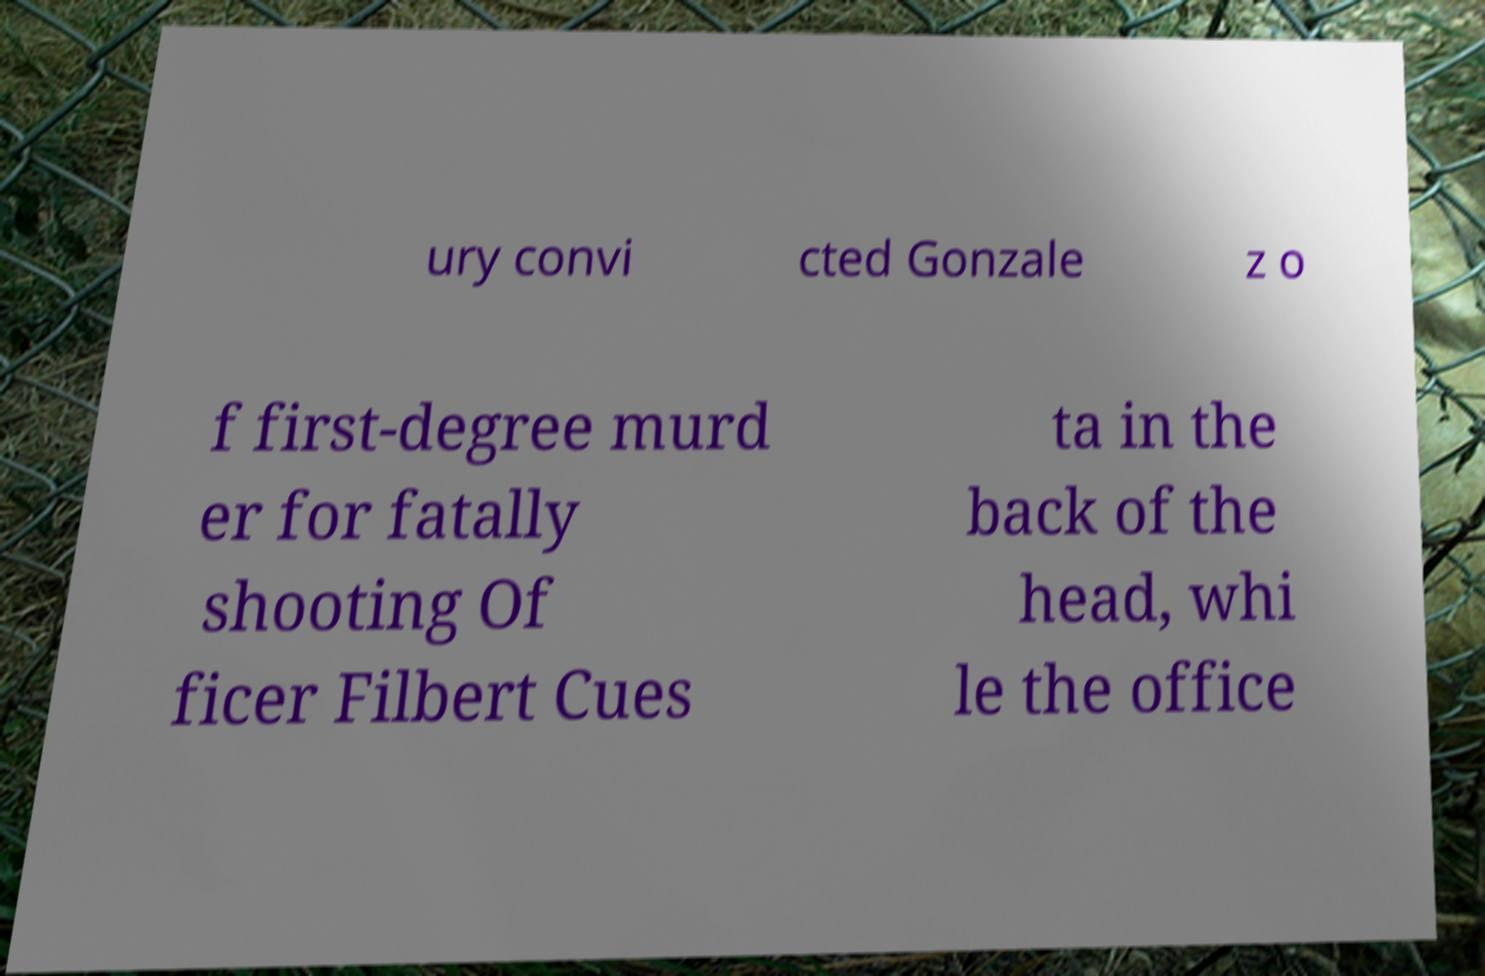Please identify and transcribe the text found in this image. ury convi cted Gonzale z o f first-degree murd er for fatally shooting Of ficer Filbert Cues ta in the back of the head, whi le the office 